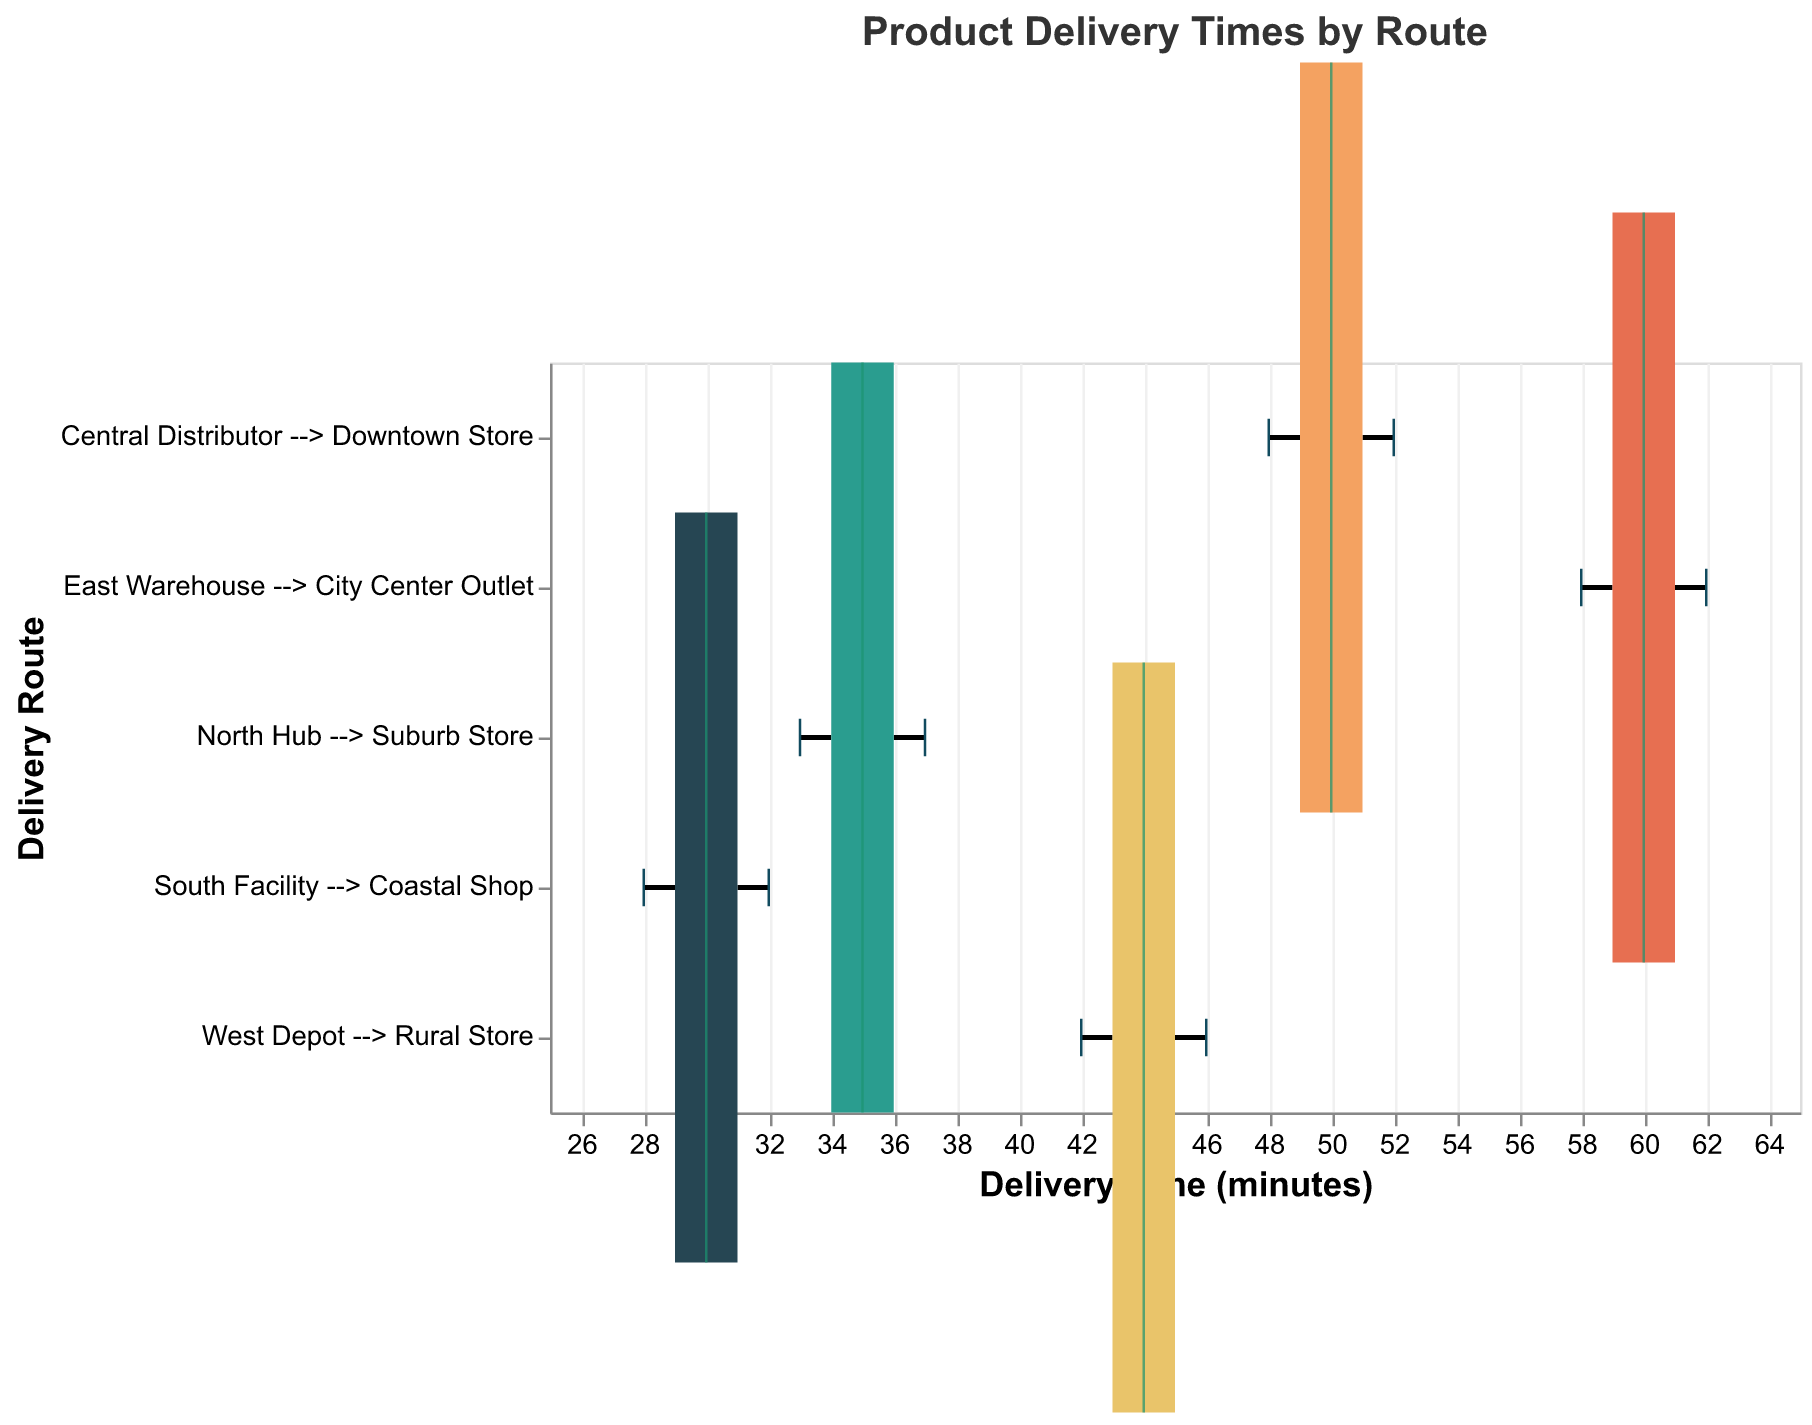What's the title of the figure? The title is the heading of the figure, typically placed at the top. In this case, it's clearly stated as "Product Delivery Times by Route".
Answer: Product Delivery Times by Route Which delivery route has the shortest median delivery time? To determine the shortest median delivery time, we look at the middle line within each boxplot. The shortest median line is for the "South Facility --> Coastal Shop" route.
Answer: South Facility --> Coastal Shop How many delivery times are recorded for the West Depot --> Rural Store route? The width of the boxplot signifies the number of data points. By observing the width, we can count that "West Depot --> Rural Store" has a width corresponding to 5 data points.
Answer: 5 What is the range of delivery times for the East Warehouse --> City Center Outlet route? The range is determined by looking at the "whiskers" or the lines extending from the top and bottom of the box. For the "East Warehouse --> City Center Outlet", the range is from 58 to 62 minutes.
Answer: 58 to 62 minutes Which route has the highest variability in delivery times? Variability is indicated by the length of the box and whiskers. The route with the longest box and whiskers, "East Warehouse --> City Center Outlet", shows the highest variability.
Answer: East Warehouse --> City Center Outlet Compare the median delivery times for North Hub --> Suburb Store and West Depot --> Rural Store. Which one is higher? To compare medians, look at the middle lines in the boxplot for each route. The median for "West Depot --> Rural Store" (45 minutes) is higher than "North Hub --> Suburb Store" (35 minutes).
Answer: West Depot --> Rural Store What are the upper and lower quartiles of delivery times for the Central Distributor --> Downtown Store route? To find the quartiles, observe the top and bottom edges of the box. For "Central Distributor --> Downtown Store", the lower quartile is 49 minutes, and the upper quartile is 51 minutes.
Answer: 49 and 51 minutes Which route has the least delivery time variability and what does it imply? The least variability route is the one with the shortest box and whiskers. "South Facility --> Coastal Shop" has the shortest spread, implying more consistent delivery times.
Answer: South Facility --> Coastal Shop What is the interquartile range for South Facility --> Coastal Shop and what does it represent? The interquartile range (IQR) is the difference between the upper and lower quartiles. For "South Facility --> Coastal Shop", the IQR is 31-29 = 2 minutes, representing the middle 50% of the data.
Answer: 2 minutes 